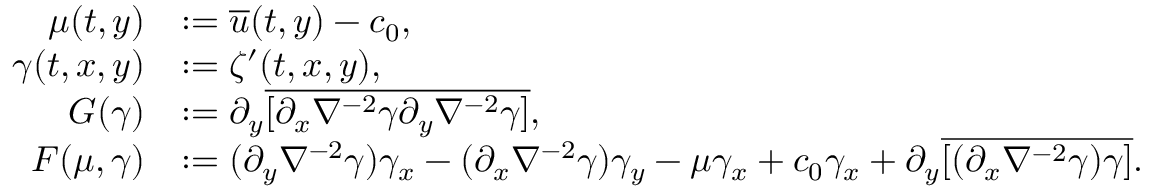Convert formula to latex. <formula><loc_0><loc_0><loc_500><loc_500>\begin{array} { r l } { \mu ( t , y ) } & { \colon = \overline { u } ( t , y ) - c _ { 0 } , } \\ { \gamma ( t , x , y ) } & { \colon = \zeta ^ { \prime } ( t , x , y ) , } \\ { G ( \gamma ) } & { \colon = \partial _ { y } \overline { { [ \partial _ { x } \nabla ^ { - 2 } \gamma \partial _ { y } \nabla ^ { - 2 } \gamma ] } } , } \\ { F ( \mu , \gamma ) } & { \colon = ( \partial _ { y } \nabla ^ { - 2 } \gamma ) \gamma _ { x } - ( \partial _ { x } \nabla ^ { - 2 } \gamma ) \gamma _ { y } - \mu \gamma _ { x } + c _ { 0 } \gamma _ { x } + \partial _ { y } \overline { { [ ( \partial _ { x } \nabla ^ { - 2 } \gamma ) \gamma ] } } . } \end{array}</formula> 